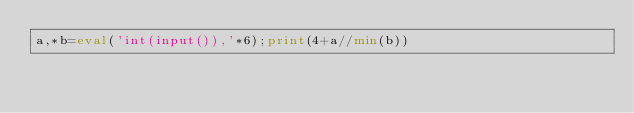Convert code to text. <code><loc_0><loc_0><loc_500><loc_500><_Python_>a,*b=eval('int(input()),'*6);print(4+a//min(b))</code> 